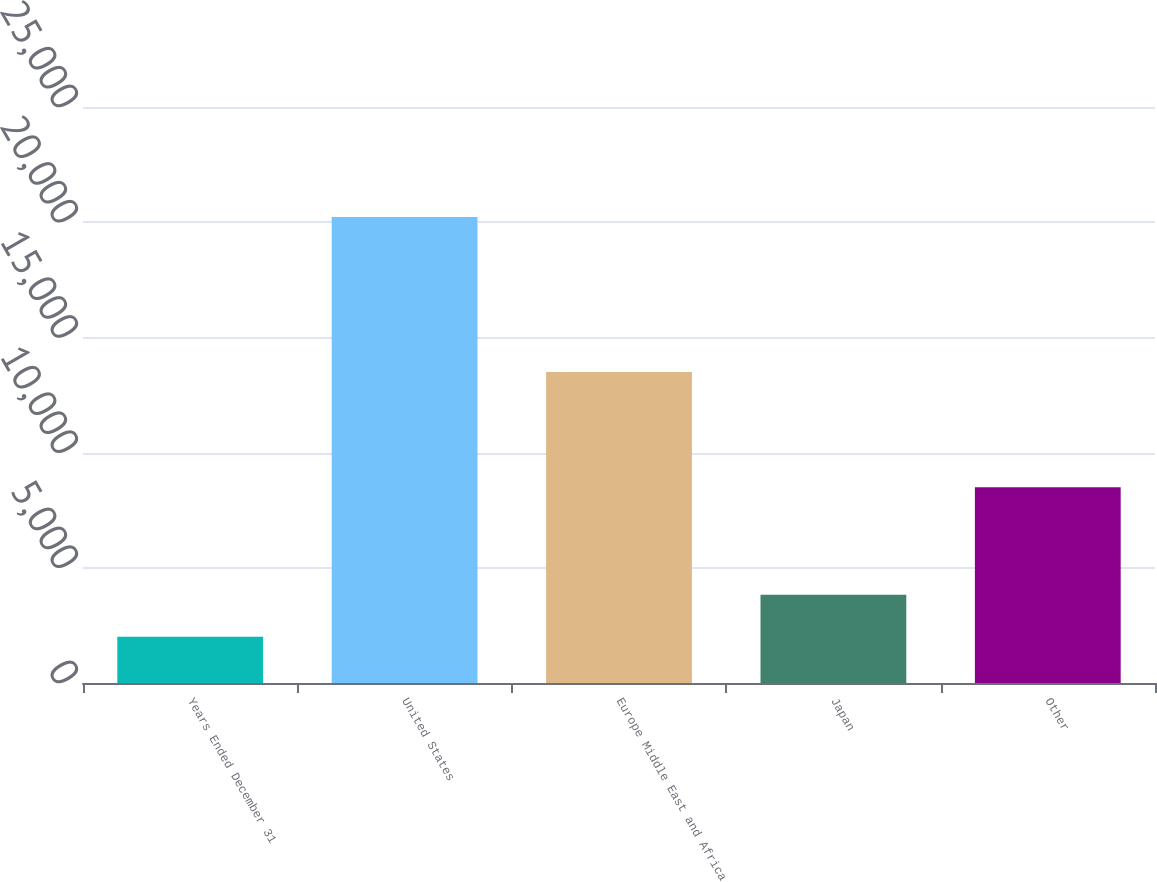<chart> <loc_0><loc_0><loc_500><loc_500><bar_chart><fcel>Years Ended December 31<fcel>United States<fcel>Europe Middle East and Africa<fcel>Japan<fcel>Other<nl><fcel>2010<fcel>20226<fcel>13497<fcel>3831.6<fcel>8496<nl></chart> 